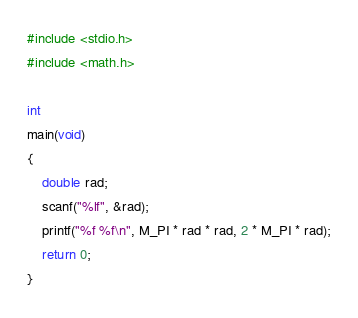<code> <loc_0><loc_0><loc_500><loc_500><_C_>#include <stdio.h>
#include <math.h>

int
main(void)
{
    double rad;
    scanf("%lf", &rad);
    printf("%f %f\n", M_PI * rad * rad, 2 * M_PI * rad);
    return 0;
}
</code> 